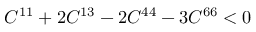Convert formula to latex. <formula><loc_0><loc_0><loc_500><loc_500>C ^ { 1 1 } + 2 C ^ { 1 3 } - 2 C ^ { 4 4 } - 3 C ^ { 6 6 } < 0</formula> 